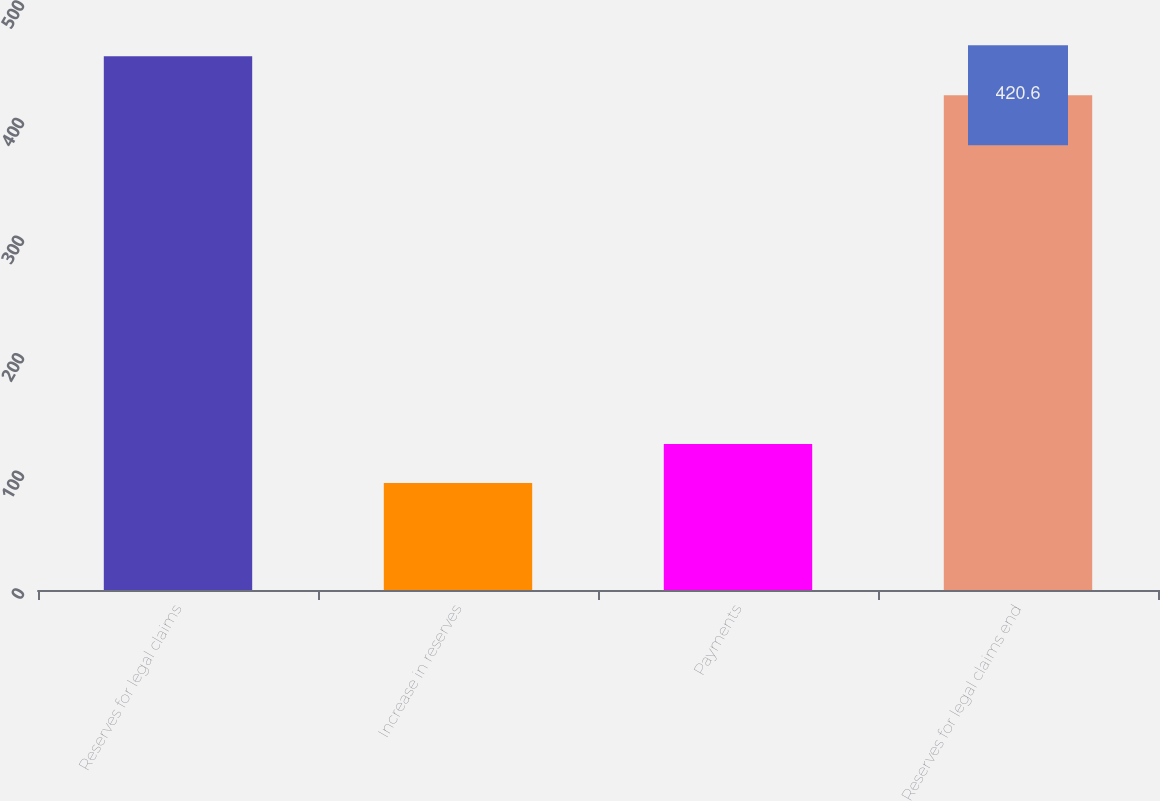<chart> <loc_0><loc_0><loc_500><loc_500><bar_chart><fcel>Reserves for legal claims<fcel>Increase in reserves<fcel>Payments<fcel>Reserves for legal claims end<nl><fcel>453.85<fcel>91<fcel>124.25<fcel>420.6<nl></chart> 